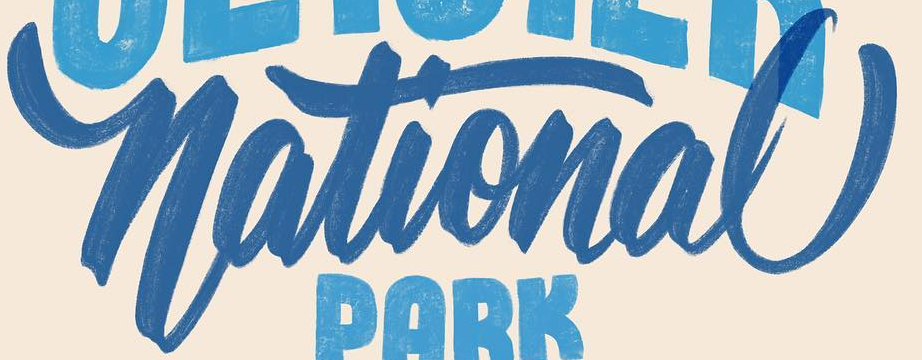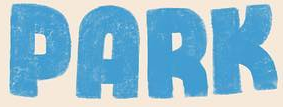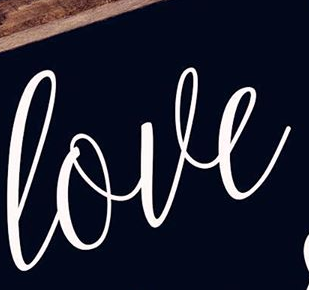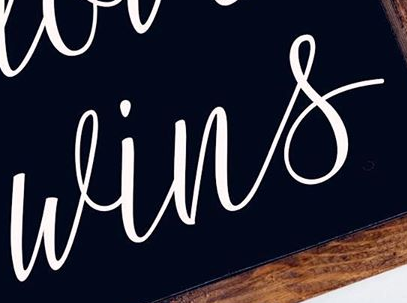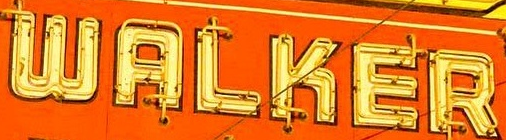What text appears in these images from left to right, separated by a semicolon? National; PARK; love; wins; WALKER 